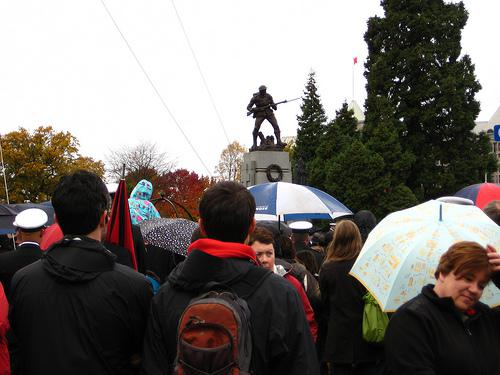Question: what do people have?
Choices:
A. Raincoats.
B. Umbrellas.
C. Pants.
D. Shirts.
Answer with the letter. Answer: B Question: what are they next to?
Choices:
A. Trees.
B. Shrubs.
C. Bushes.
D. Wall.
Answer with the letter. Answer: A Question: who is gathering?
Choices:
A. Men.
B. Women.
C. Children.
D. People.
Answer with the letter. Answer: D Question: what is on the guys back?
Choices:
A. Child.
B. Backpack.
C. Jacket.
D. Tattoos.
Answer with the letter. Answer: B 